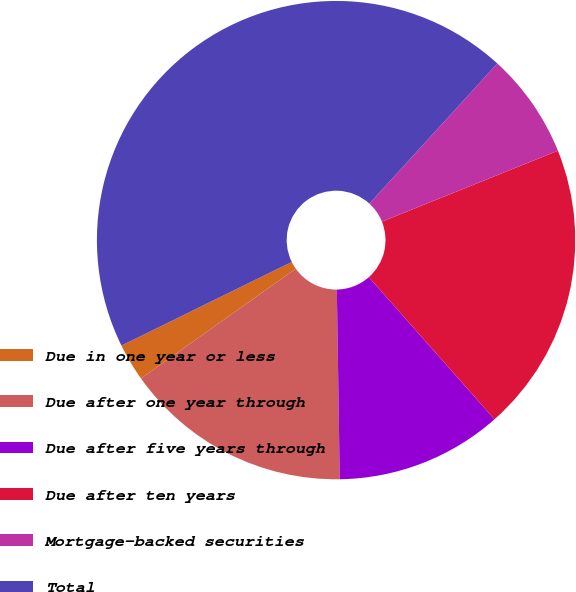<chart> <loc_0><loc_0><loc_500><loc_500><pie_chart><fcel>Due in one year or less<fcel>Due after one year through<fcel>Due after five years through<fcel>Due after ten years<fcel>Mortgage-backed securities<fcel>Total<nl><fcel>2.55%<fcel>15.43%<fcel>11.28%<fcel>19.58%<fcel>7.13%<fcel>44.05%<nl></chart> 